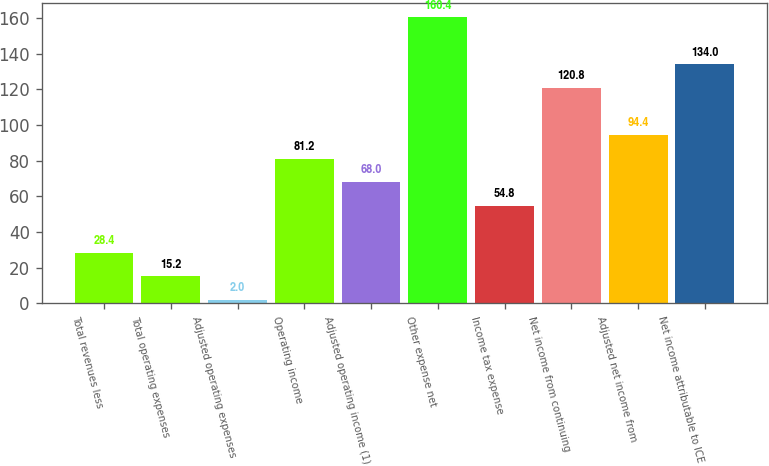Convert chart to OTSL. <chart><loc_0><loc_0><loc_500><loc_500><bar_chart><fcel>Total revenues less<fcel>Total operating expenses<fcel>Adjusted operating expenses<fcel>Operating income<fcel>Adjusted operating income (1)<fcel>Other expense net<fcel>Income tax expense<fcel>Net income from continuing<fcel>Adjusted net income from<fcel>Net income attributable to ICE<nl><fcel>28.4<fcel>15.2<fcel>2<fcel>81.2<fcel>68<fcel>160.4<fcel>54.8<fcel>120.8<fcel>94.4<fcel>134<nl></chart> 